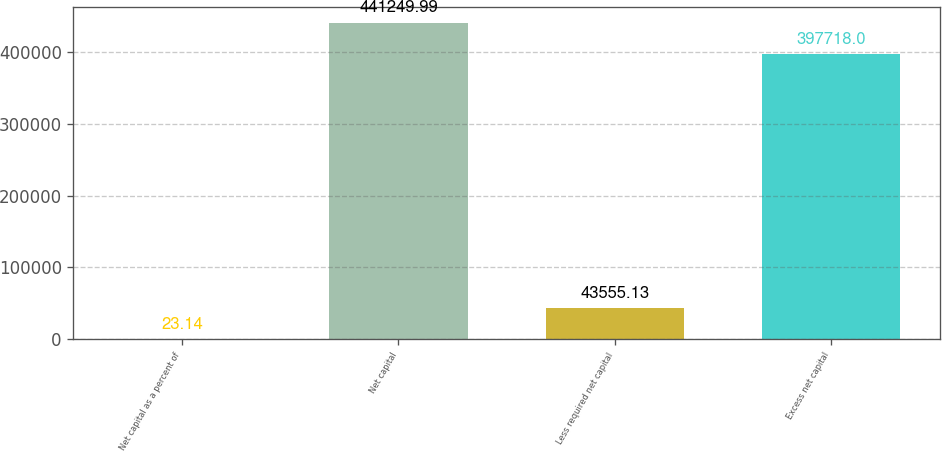Convert chart. <chart><loc_0><loc_0><loc_500><loc_500><bar_chart><fcel>Net capital as a percent of<fcel>Net capital<fcel>Less required net capital<fcel>Excess net capital<nl><fcel>23.14<fcel>441250<fcel>43555.1<fcel>397718<nl></chart> 